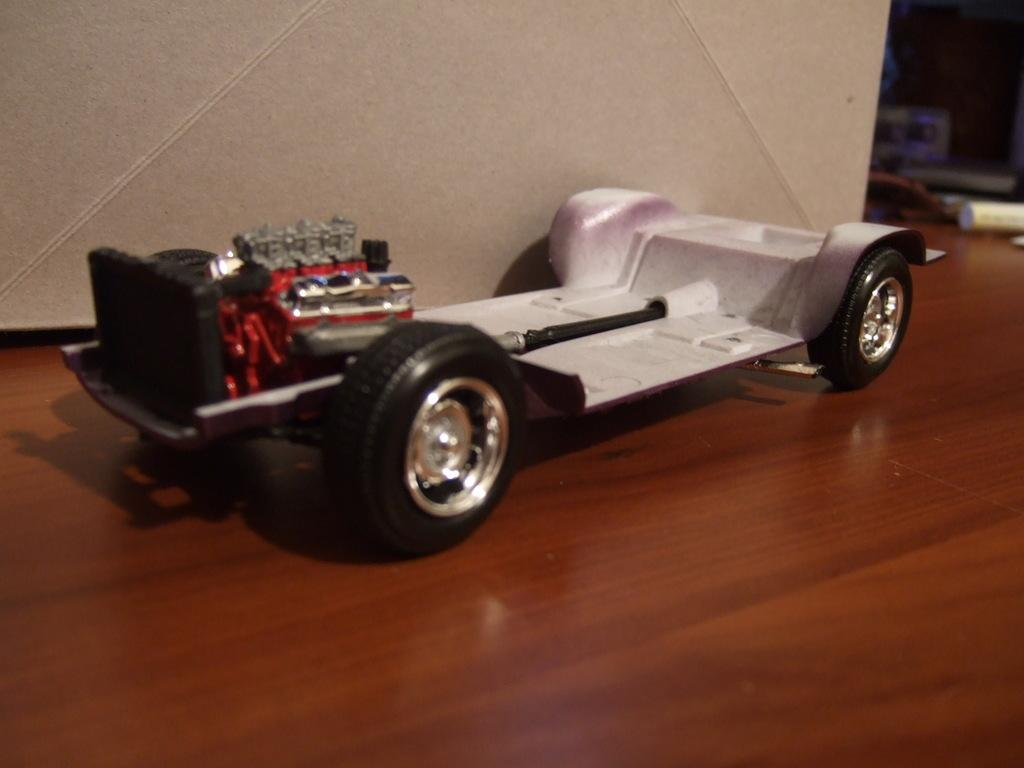What is the main object in the image? There is a toy car in the image. What type of surface is the toy car placed on? The toy car is on a wooden surface. How many docks are visible in the image? There are no docks present in the image. What type of stick is being used to play with the toy car in the image? There is no stick present in the image, and the toy car is not being played with. 